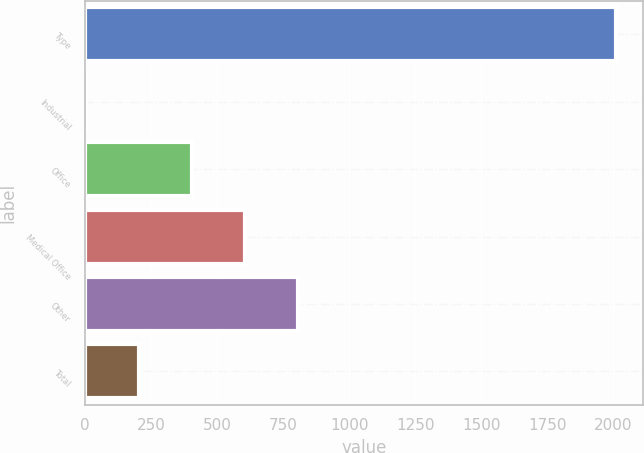Convert chart to OTSL. <chart><loc_0><loc_0><loc_500><loc_500><bar_chart><fcel>Type<fcel>Industrial<fcel>Office<fcel>Medical Office<fcel>Other<fcel>Total<nl><fcel>2011<fcel>3.9<fcel>405.32<fcel>606.03<fcel>806.74<fcel>204.61<nl></chart> 